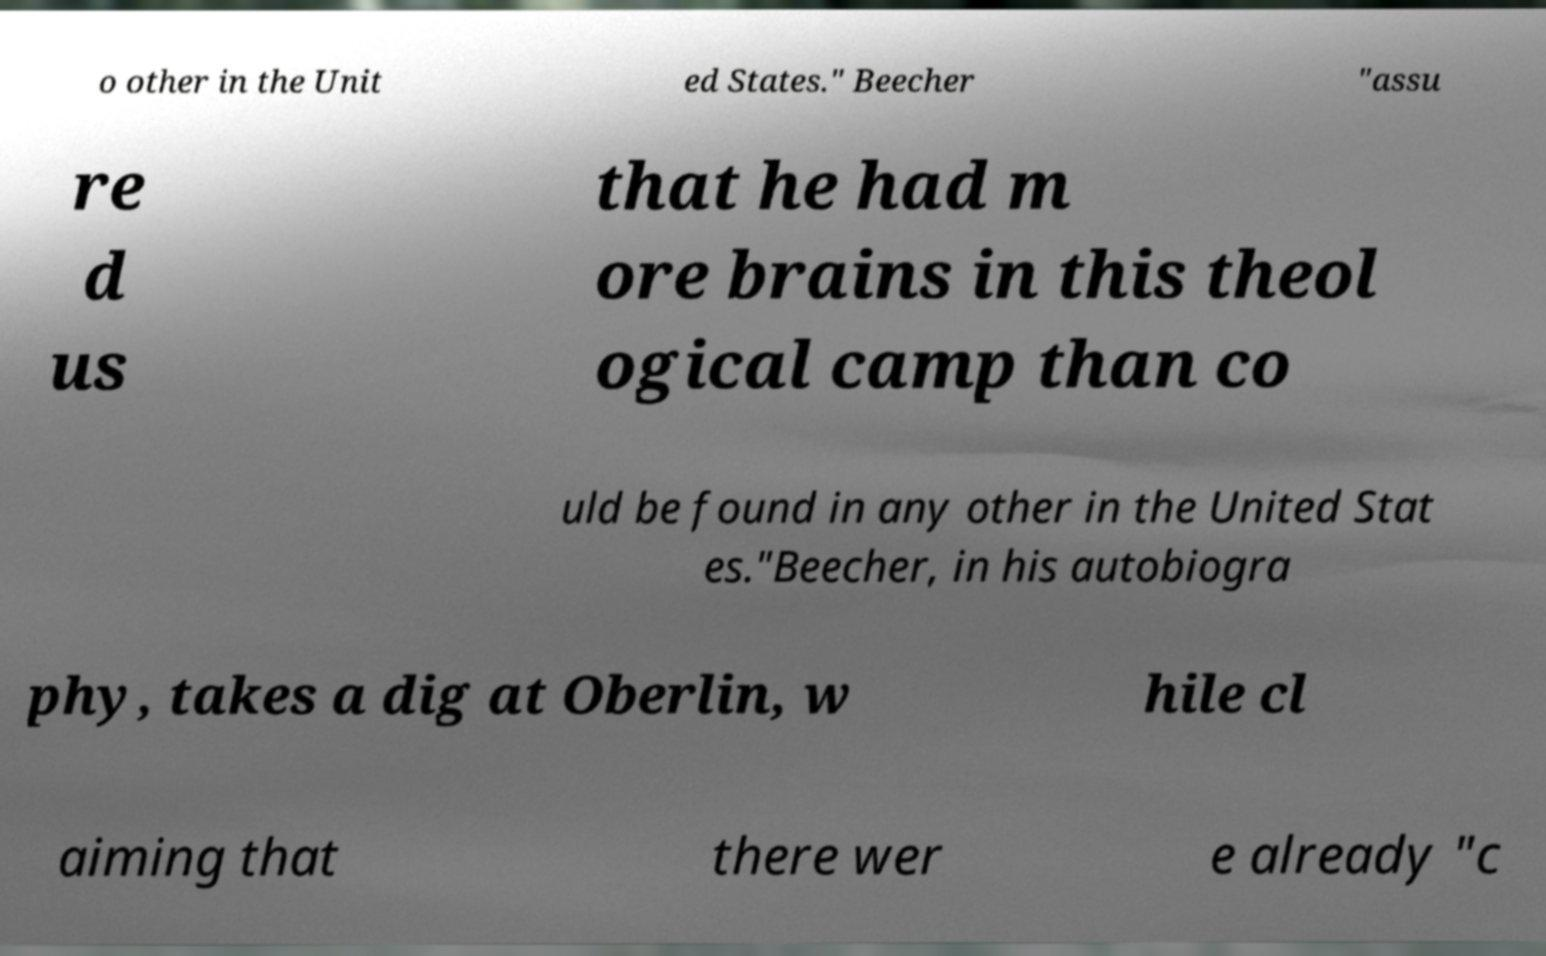For documentation purposes, I need the text within this image transcribed. Could you provide that? o other in the Unit ed States." Beecher "assu re d us that he had m ore brains in this theol ogical camp than co uld be found in any other in the United Stat es."Beecher, in his autobiogra phy, takes a dig at Oberlin, w hile cl aiming that there wer e already "c 